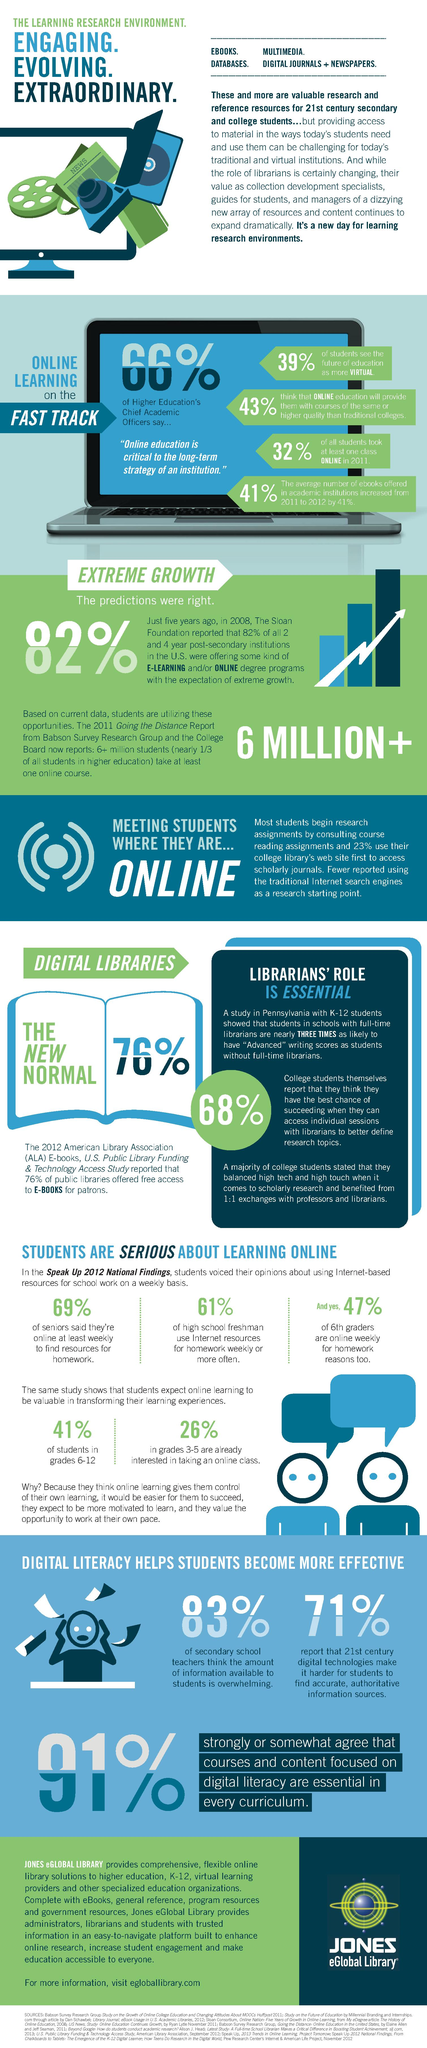Indicate a few pertinent items in this graphic. According to the study, 41% of students in grades 6-12 expect online learning to be valuable in transforming their learning experience. In 2011, 32% of all students took at least one online class. Approximately 25% of students in grades 3-5 are already interested in taking an online class, as indicated by the study. According to the study, 61% of high school freshman use internet resources for homework weekly or more often. According to a study, a majority of secondary school teachers, which is 83%, believe that the amount of information available to students in digital form is overwhelming. 